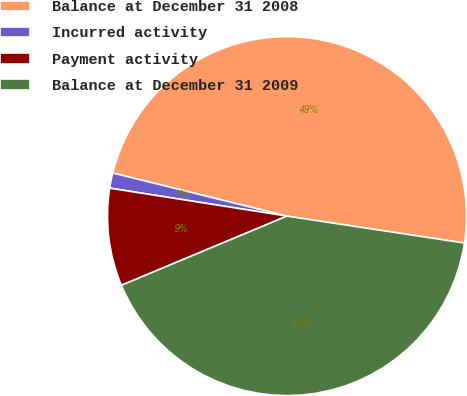<chart> <loc_0><loc_0><loc_500><loc_500><pie_chart><fcel>Balance at December 31 2008<fcel>Incurred activity<fcel>Payment activity<fcel>Balance at December 31 2009<nl><fcel>48.54%<fcel>1.37%<fcel>8.79%<fcel>41.3%<nl></chart> 